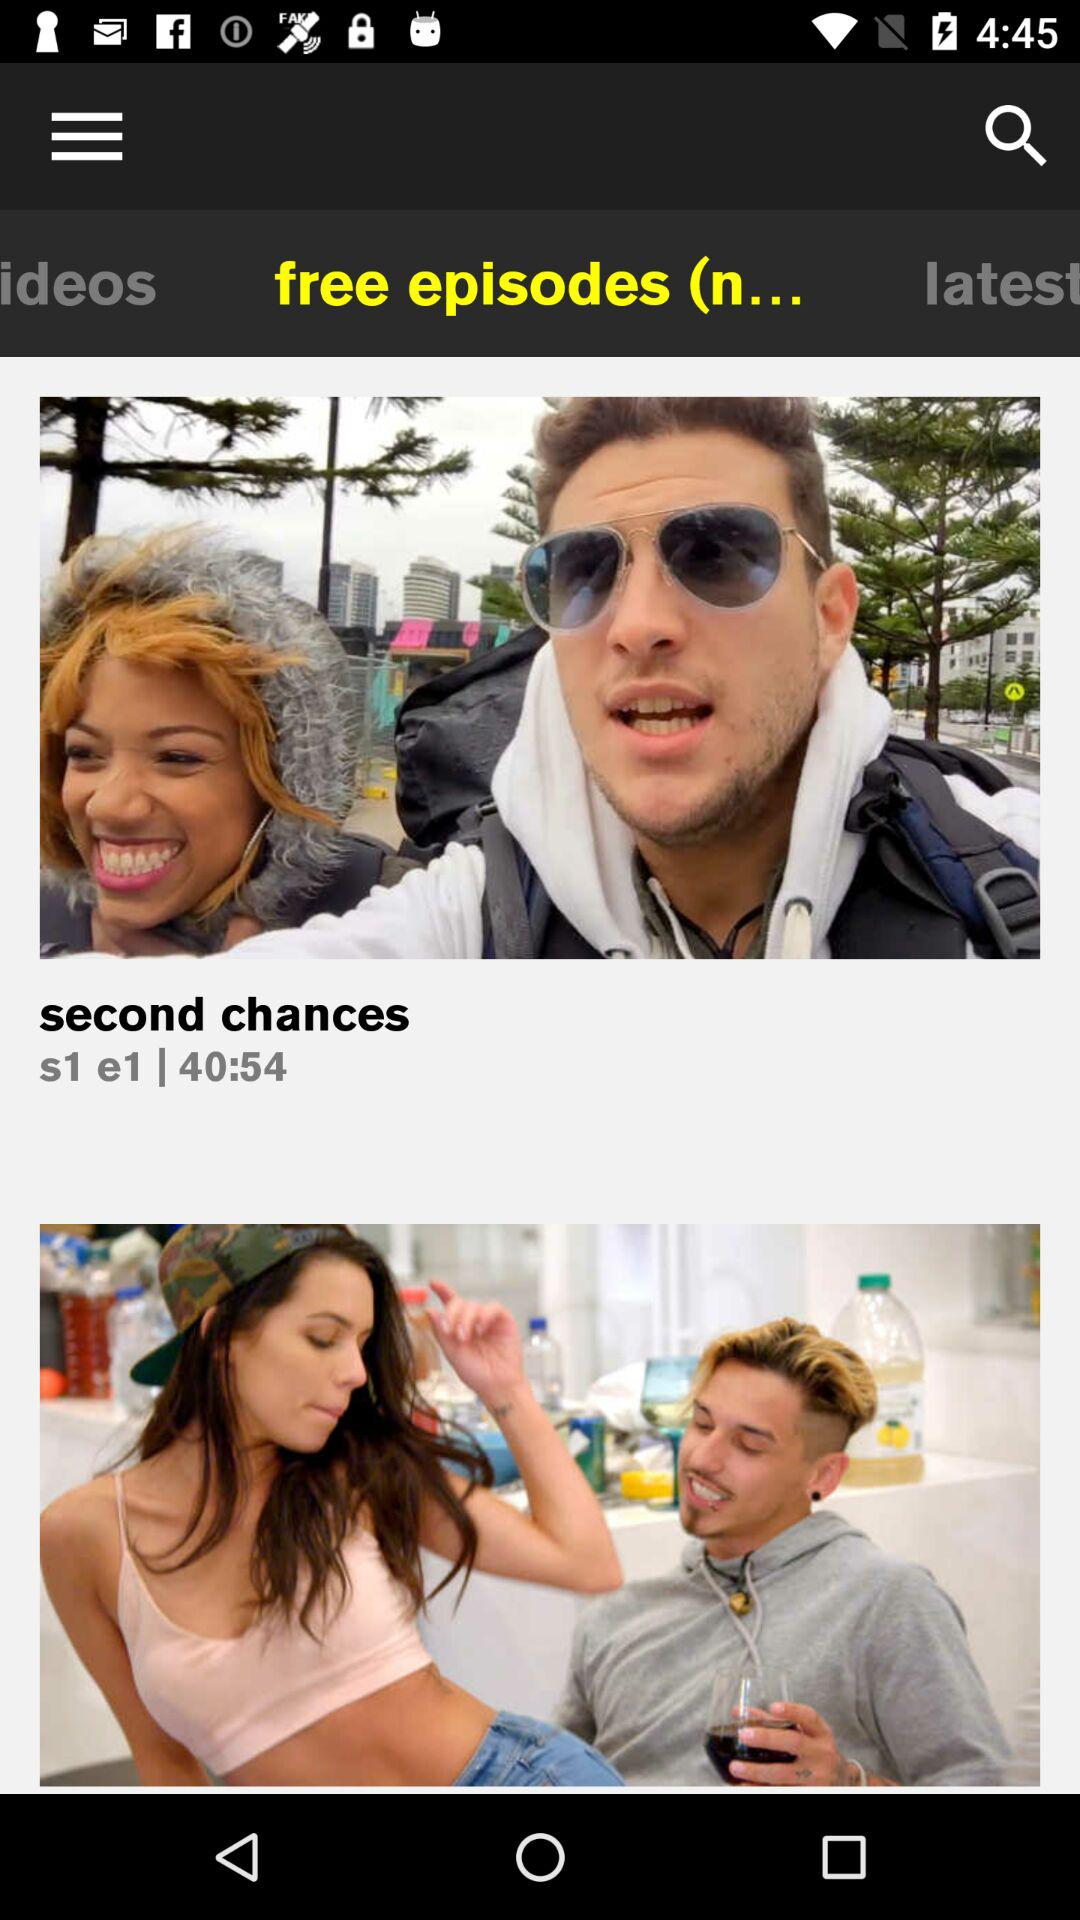Which tab is selected? The selected tab is "free episodes (n...". 